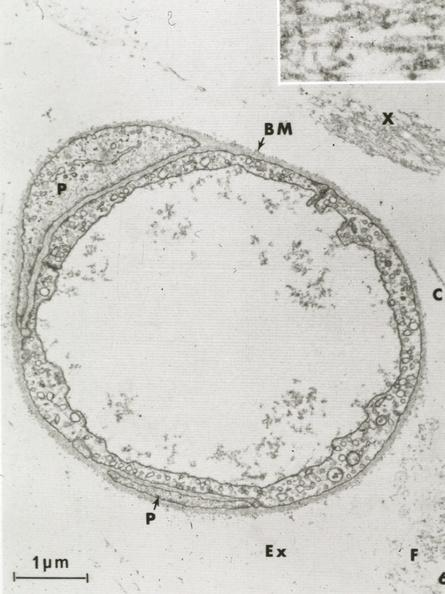s capillary present?
Answer the question using a single word or phrase. Yes 